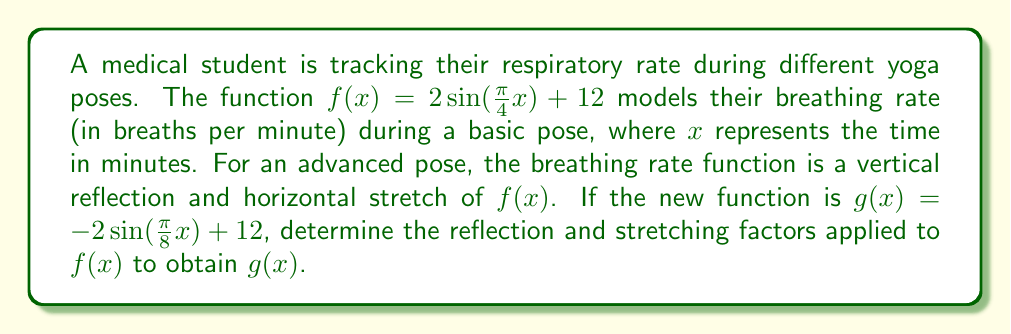Show me your answer to this math problem. Let's approach this step-by-step:

1) The general form of a sine function is:
   $$y = A\sin(B(x-C)) + D$$
   where $A$ is the amplitude, $B$ is the frequency, $C$ is the phase shift, and $D$ is the vertical shift.

2) For $f(x) = 2\sin(\frac{\pi}{4}x) + 12$:
   $A = 2$, $B = \frac{\pi}{4}$, $C = 0$, and $D = 12$

3) For $g(x) = -2\sin(\frac{\pi}{8}x) + 12$:
   $A = -2$, $B = \frac{\pi}{8}$, $C = 0$, and $D = 12$

4) Vertical reflection:
   The amplitude $A$ changed from 2 to -2. This indicates a reflection across the x-axis, which is achieved by multiplying the function by -1.

5) Horizontal stretch:
   The frequency $B$ changed from $\frac{\pi}{4}$ to $\frac{\pi}{8}$. To determine the stretch factor, we divide the original frequency by the new frequency:
   $$\text{Stretch factor} = \frac{\frac{\pi}{4}}{\frac{\pi}{8}} = \frac{\pi}{4} \cdot \frac{8}{\pi} = 2$$
   This means the function was stretched horizontally by a factor of 2.

6) To express $g(x)$ in terms of $f(x)$:
   $$g(x) = -f(\frac{1}{2}x)$$
   The negative sign represents the reflection, and $\frac{1}{2}x$ represents the horizontal stretch by a factor of 2.
Answer: Vertical reflection: -1; Horizontal stretch: 2 